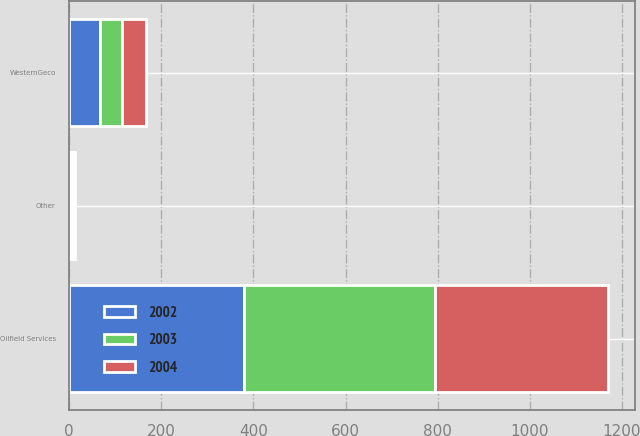Convert chart. <chart><loc_0><loc_0><loc_500><loc_500><stacked_bar_chart><ecel><fcel>Oilfield Services<fcel>WesternGeco<fcel>Other<nl><fcel>2003<fcel>416<fcel>48<fcel>3<nl><fcel>2004<fcel>375<fcel>52<fcel>4<nl><fcel>2002<fcel>379<fcel>68<fcel>5<nl></chart> 